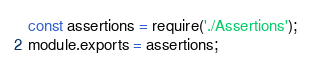Convert code to text. <code><loc_0><loc_0><loc_500><loc_500><_JavaScript_>const assertions = require('./Assertions');
module.exports = assertions;
</code> 